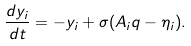<formula> <loc_0><loc_0><loc_500><loc_500>\frac { d y _ { i } } { d t } = - y _ { i } + \sigma ( { A } _ { i } q - \eta _ { i } ) .</formula> 